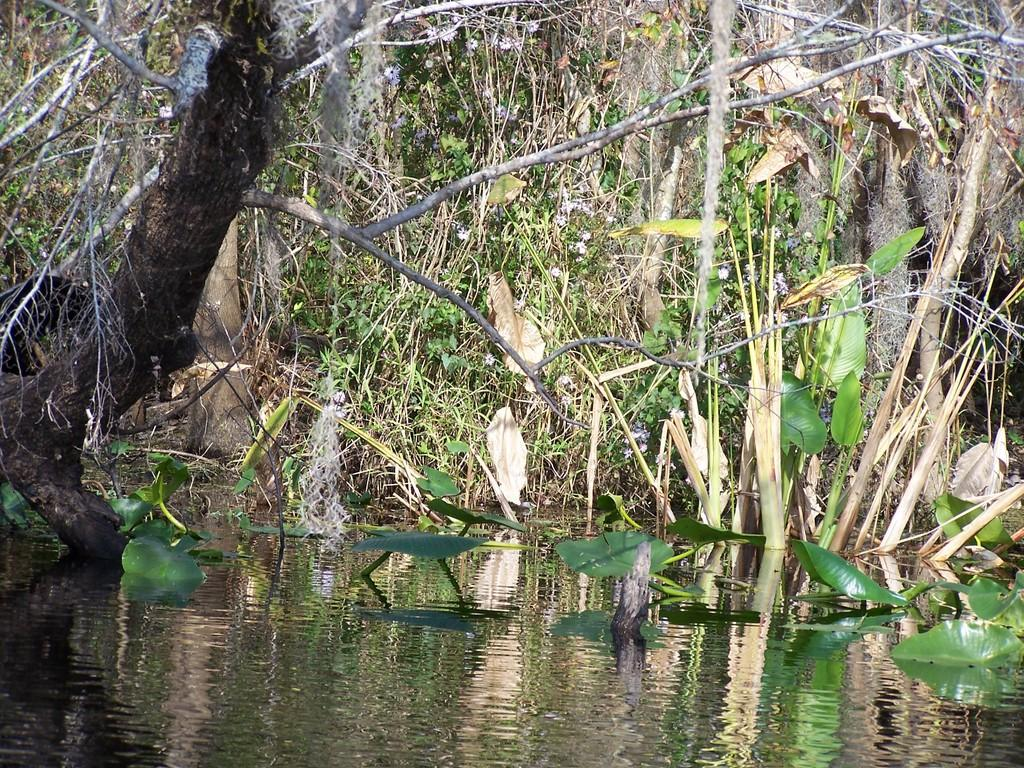What type of living organisms can be seen in the image? Plants can be seen in the image. What is the primary element visible in the image? Water is visible in the image. What type of powder can be seen falling on the plants in the image? There is no powder visible in the image; only plants and water are present. How many stitches are visible on the plants in the image? Plants do not have stitches, so there are none visible in the image. 